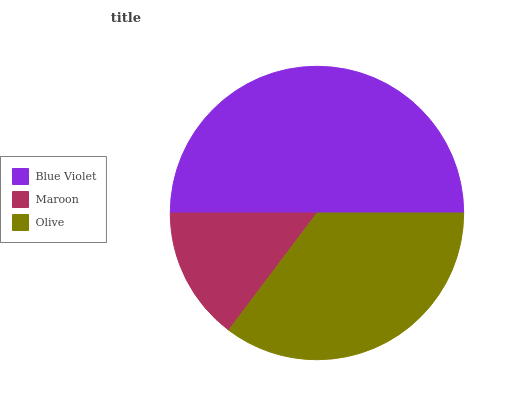Is Maroon the minimum?
Answer yes or no. Yes. Is Blue Violet the maximum?
Answer yes or no. Yes. Is Olive the minimum?
Answer yes or no. No. Is Olive the maximum?
Answer yes or no. No. Is Olive greater than Maroon?
Answer yes or no. Yes. Is Maroon less than Olive?
Answer yes or no. Yes. Is Maroon greater than Olive?
Answer yes or no. No. Is Olive less than Maroon?
Answer yes or no. No. Is Olive the high median?
Answer yes or no. Yes. Is Olive the low median?
Answer yes or no. Yes. Is Blue Violet the high median?
Answer yes or no. No. Is Maroon the low median?
Answer yes or no. No. 